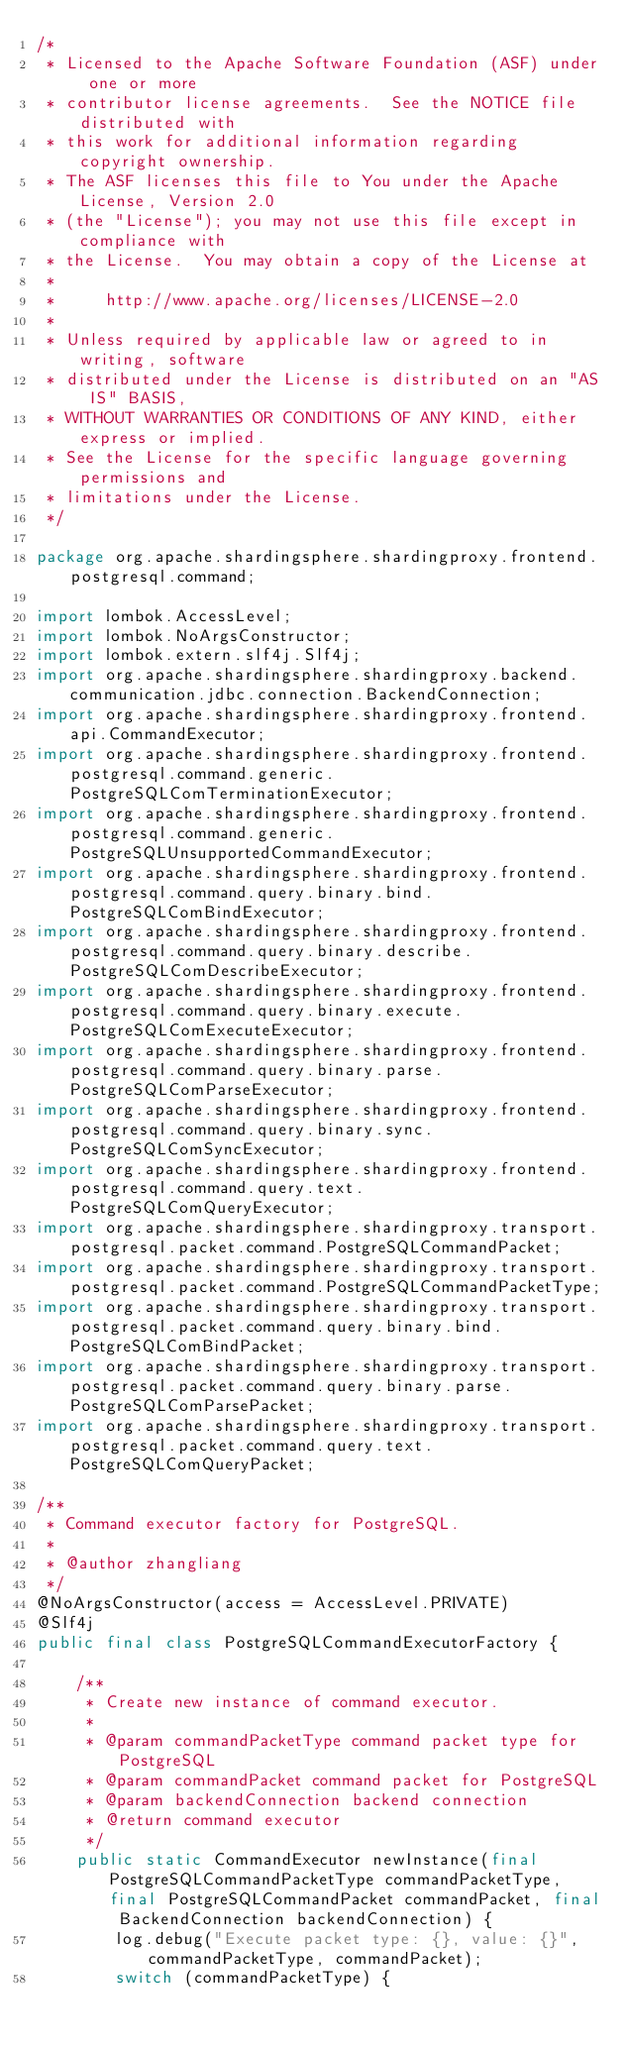<code> <loc_0><loc_0><loc_500><loc_500><_Java_>/*
 * Licensed to the Apache Software Foundation (ASF) under one or more
 * contributor license agreements.  See the NOTICE file distributed with
 * this work for additional information regarding copyright ownership.
 * The ASF licenses this file to You under the Apache License, Version 2.0
 * (the "License"); you may not use this file except in compliance with
 * the License.  You may obtain a copy of the License at
 *
 *     http://www.apache.org/licenses/LICENSE-2.0
 *
 * Unless required by applicable law or agreed to in writing, software
 * distributed under the License is distributed on an "AS IS" BASIS,
 * WITHOUT WARRANTIES OR CONDITIONS OF ANY KIND, either express or implied.
 * See the License for the specific language governing permissions and
 * limitations under the License.
 */

package org.apache.shardingsphere.shardingproxy.frontend.postgresql.command;

import lombok.AccessLevel;
import lombok.NoArgsConstructor;
import lombok.extern.slf4j.Slf4j;
import org.apache.shardingsphere.shardingproxy.backend.communication.jdbc.connection.BackendConnection;
import org.apache.shardingsphere.shardingproxy.frontend.api.CommandExecutor;
import org.apache.shardingsphere.shardingproxy.frontend.postgresql.command.generic.PostgreSQLComTerminationExecutor;
import org.apache.shardingsphere.shardingproxy.frontend.postgresql.command.generic.PostgreSQLUnsupportedCommandExecutor;
import org.apache.shardingsphere.shardingproxy.frontend.postgresql.command.query.binary.bind.PostgreSQLComBindExecutor;
import org.apache.shardingsphere.shardingproxy.frontend.postgresql.command.query.binary.describe.PostgreSQLComDescribeExecutor;
import org.apache.shardingsphere.shardingproxy.frontend.postgresql.command.query.binary.execute.PostgreSQLComExecuteExecutor;
import org.apache.shardingsphere.shardingproxy.frontend.postgresql.command.query.binary.parse.PostgreSQLComParseExecutor;
import org.apache.shardingsphere.shardingproxy.frontend.postgresql.command.query.binary.sync.PostgreSQLComSyncExecutor;
import org.apache.shardingsphere.shardingproxy.frontend.postgresql.command.query.text.PostgreSQLComQueryExecutor;
import org.apache.shardingsphere.shardingproxy.transport.postgresql.packet.command.PostgreSQLCommandPacket;
import org.apache.shardingsphere.shardingproxy.transport.postgresql.packet.command.PostgreSQLCommandPacketType;
import org.apache.shardingsphere.shardingproxy.transport.postgresql.packet.command.query.binary.bind.PostgreSQLComBindPacket;
import org.apache.shardingsphere.shardingproxy.transport.postgresql.packet.command.query.binary.parse.PostgreSQLComParsePacket;
import org.apache.shardingsphere.shardingproxy.transport.postgresql.packet.command.query.text.PostgreSQLComQueryPacket;

/**
 * Command executor factory for PostgreSQL.
 *
 * @author zhangliang
 */
@NoArgsConstructor(access = AccessLevel.PRIVATE)
@Slf4j
public final class PostgreSQLCommandExecutorFactory {
    
    /**
     * Create new instance of command executor.
     *
     * @param commandPacketType command packet type for PostgreSQL
     * @param commandPacket command packet for PostgreSQL
     * @param backendConnection backend connection
     * @return command executor
     */
    public static CommandExecutor newInstance(final PostgreSQLCommandPacketType commandPacketType, final PostgreSQLCommandPacket commandPacket, final BackendConnection backendConnection) {
        log.debug("Execute packet type: {}, value: {}", commandPacketType, commandPacket);
        switch (commandPacketType) {</code> 